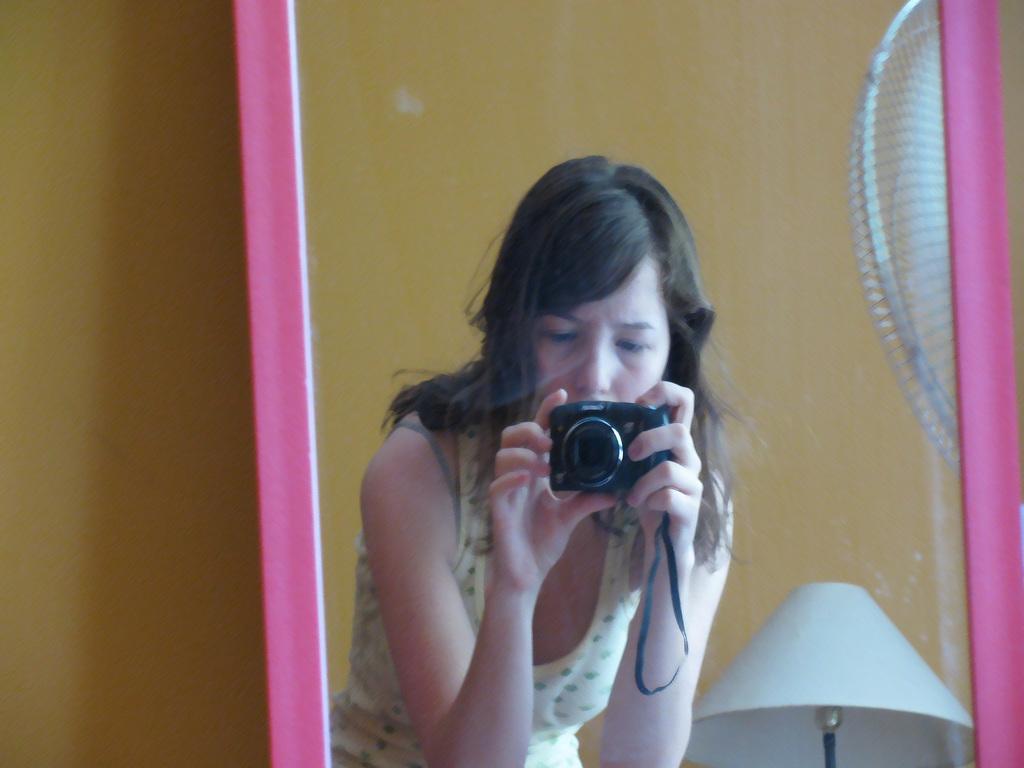Could you give a brief overview of what you see in this image? In this image we can see a mirror. In the mirror we can see reflection of a lady holding camera, lamp and part of a fan. In the background there is a wall. 